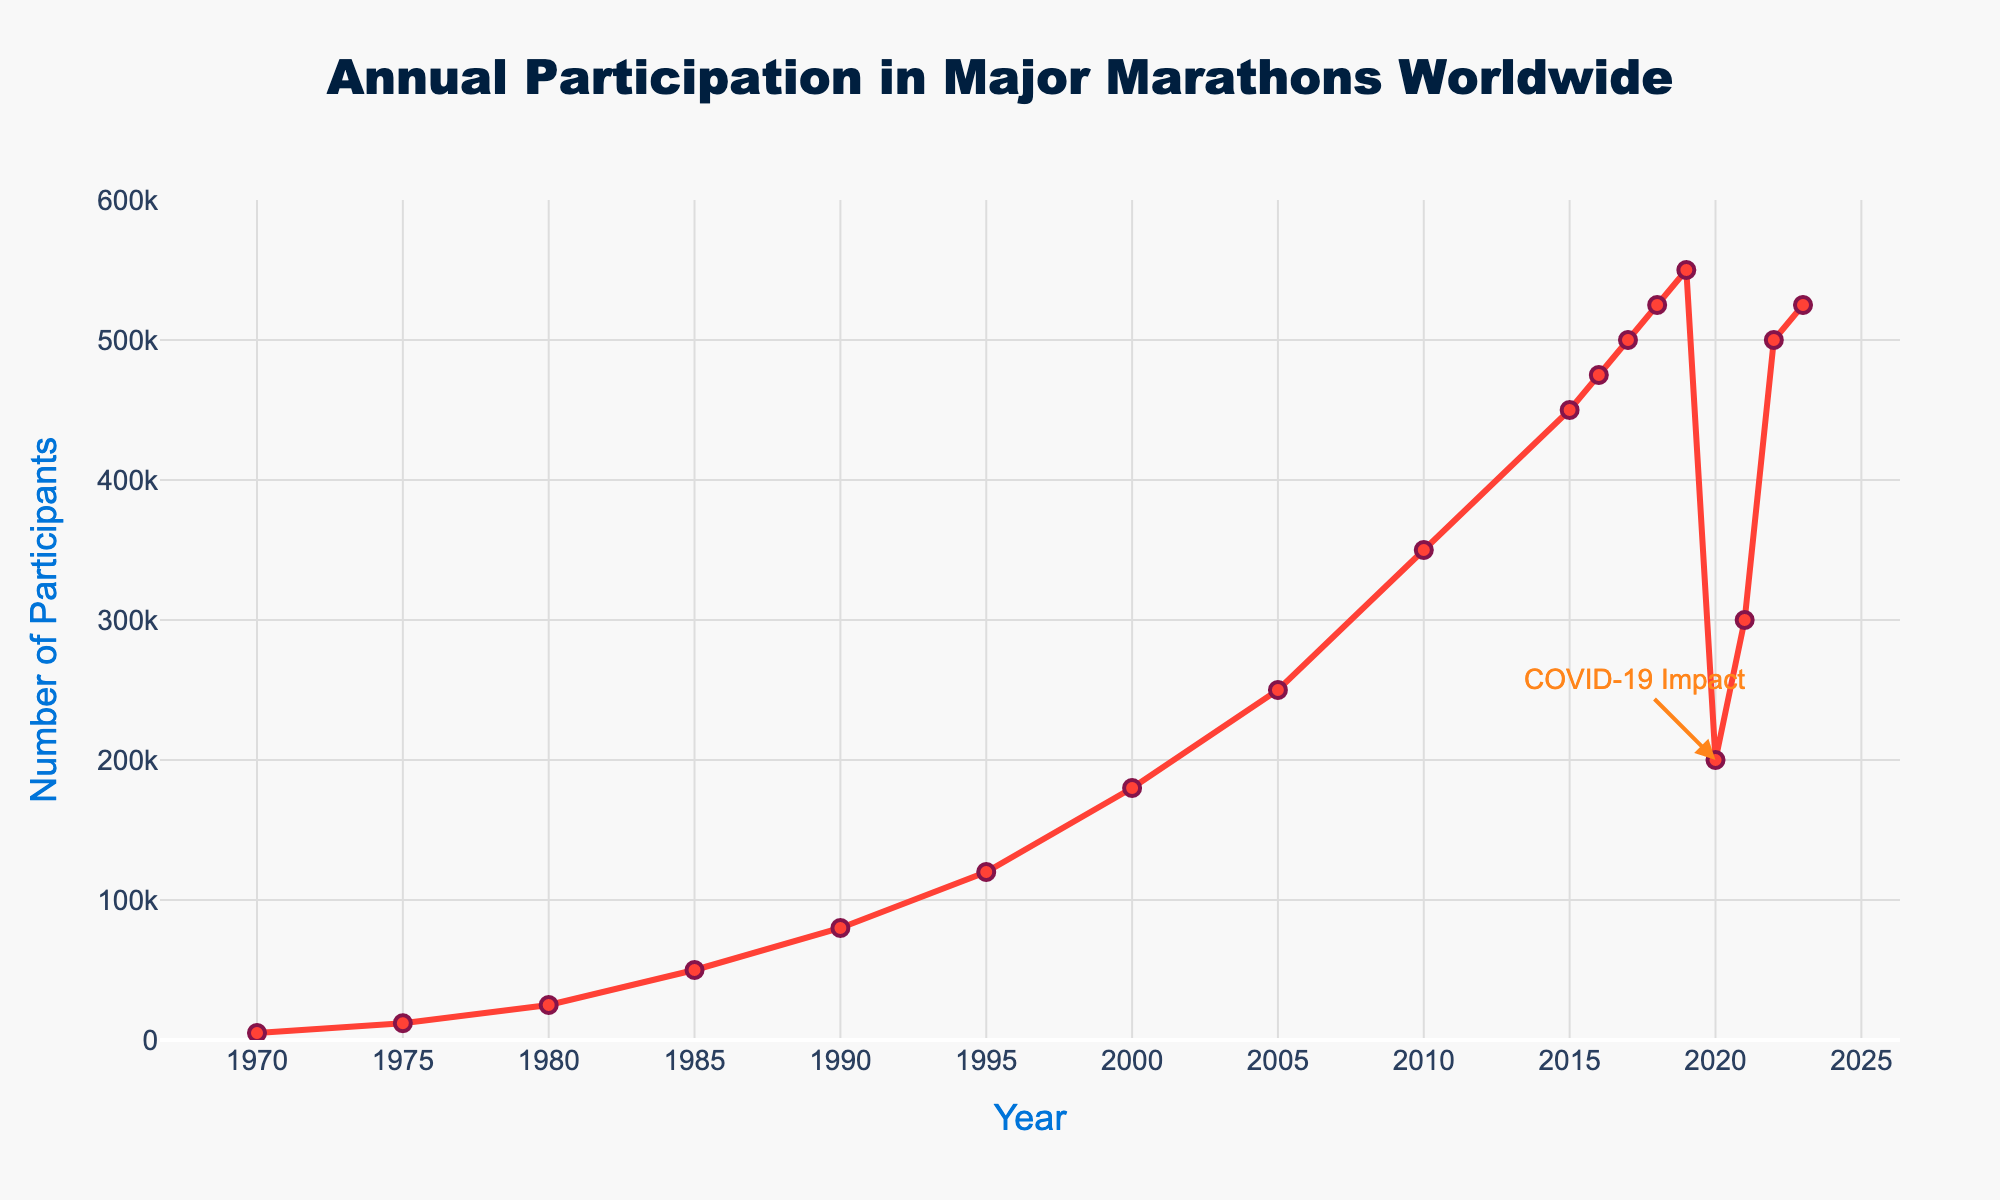What was the annual participation rate in major marathons worldwide in 1970? By looking at the figure, you can directly see the data point for the year 1970, marked by the line and marker corresponding to that year.
Answer: 5000 How did the participation rate change from 2019 to 2020? From the figure, note the number of participants in 2019 and 2020. Subtract the 2020 value from the 2019 value: 550,000 - 200,000.
Answer: Decreased by 350,000 Which year experienced the highest participation rate, and what was the rate? Reviewing the figure, find the highest data point along the y-axis and its corresponding year on the x-axis.
Answer: 2023, 525,000 How does the participation rate in 2021 compare to the rate in 2020? Compare the values for the years 2020 and 2021 directly from the figure. 2021 has a higher rate than 2020.
Answer: Higher What was the average participation rate from 1970 to 1975? Sum the participation rates for 1970 and 1975, then divide by the number of years: (5000 + 12000) / 2.
Answer: 8,500 What color is used to indicate the participants in the figure? The figure uses a specific color for the line and markers representing participants.
Answer: Red What is the COVID-19 impact annotation pointing to in the figure? The annotation is pointing to the data point in 2020 with a noticeable drop in participants.
Answer: Year 2020 Calculate the average annual participants from 2016 to 2019. Sum the participation rates from 2016 to 2019 (475,000 + 500,000 + 525,000 + 550,000), then divide by the number of years (4).
Answer: 512,500 By how much did the number of participants increase from 1995 to 2000? Using the values from the figure, subtract the number of participants in 1995 from those in 2000: 180,000 - 120,000.
Answer: Increased by 60,000 